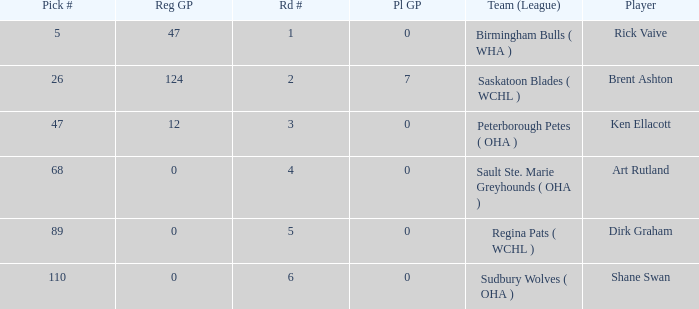How many reg GP for rick vaive in round 1? None. 